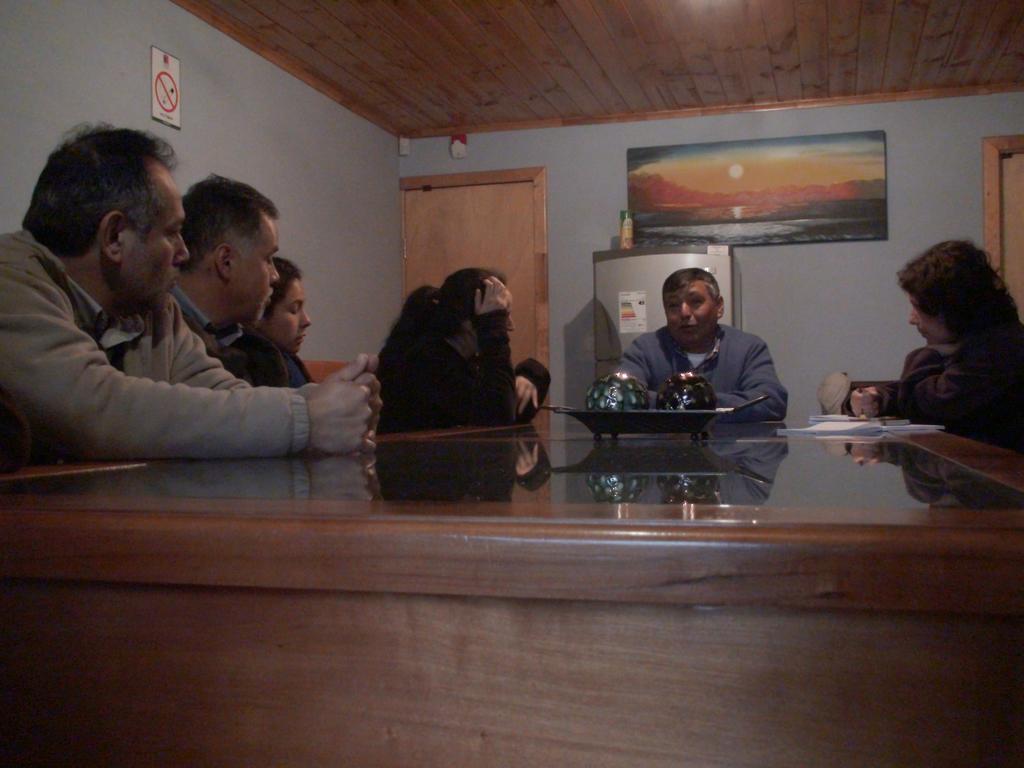Describe this image in one or two sentences. There is a brown color table,On that table there is a object which is holding two circular balls,There are some people sitting on the chairs and in the background there is a white color wall,On that wall there is a picture and there is a fridge in silver color and there are two doors in brown color. 